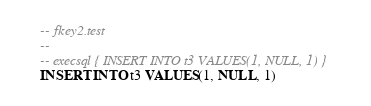Convert code to text. <code><loc_0><loc_0><loc_500><loc_500><_SQL_>-- fkey2.test
-- 
-- execsql { INSERT INTO t3 VALUES(1, NULL, 1) }
INSERT INTO t3 VALUES(1, NULL, 1)</code> 